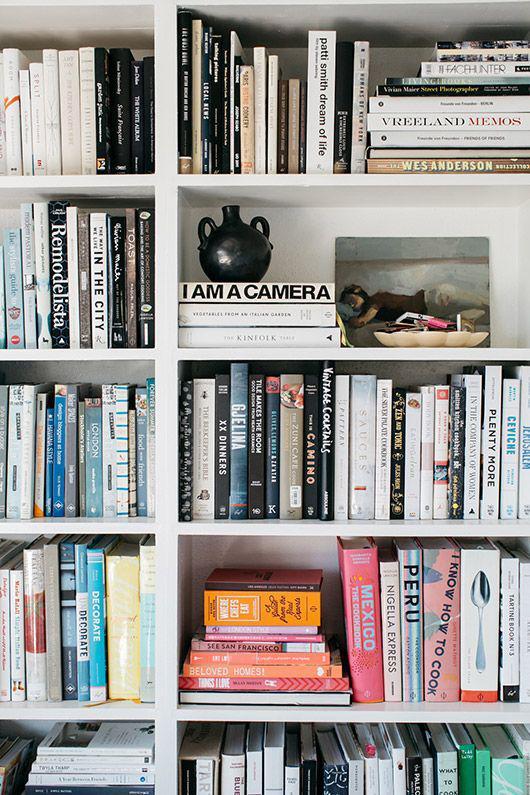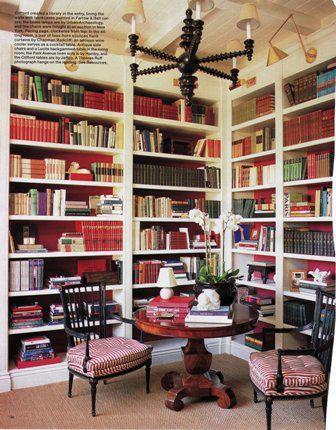The first image is the image on the left, the second image is the image on the right. Examine the images to the left and right. Is the description "In one image, a shelf unit that is two shelves wide and at least three shelves tall is open at the back to a wall with a decorative overall design." accurate? Answer yes or no. No. The first image is the image on the left, the second image is the image on the right. Considering the images on both sides, is "One of the bookcases as a patterned back wall." valid? Answer yes or no. No. 